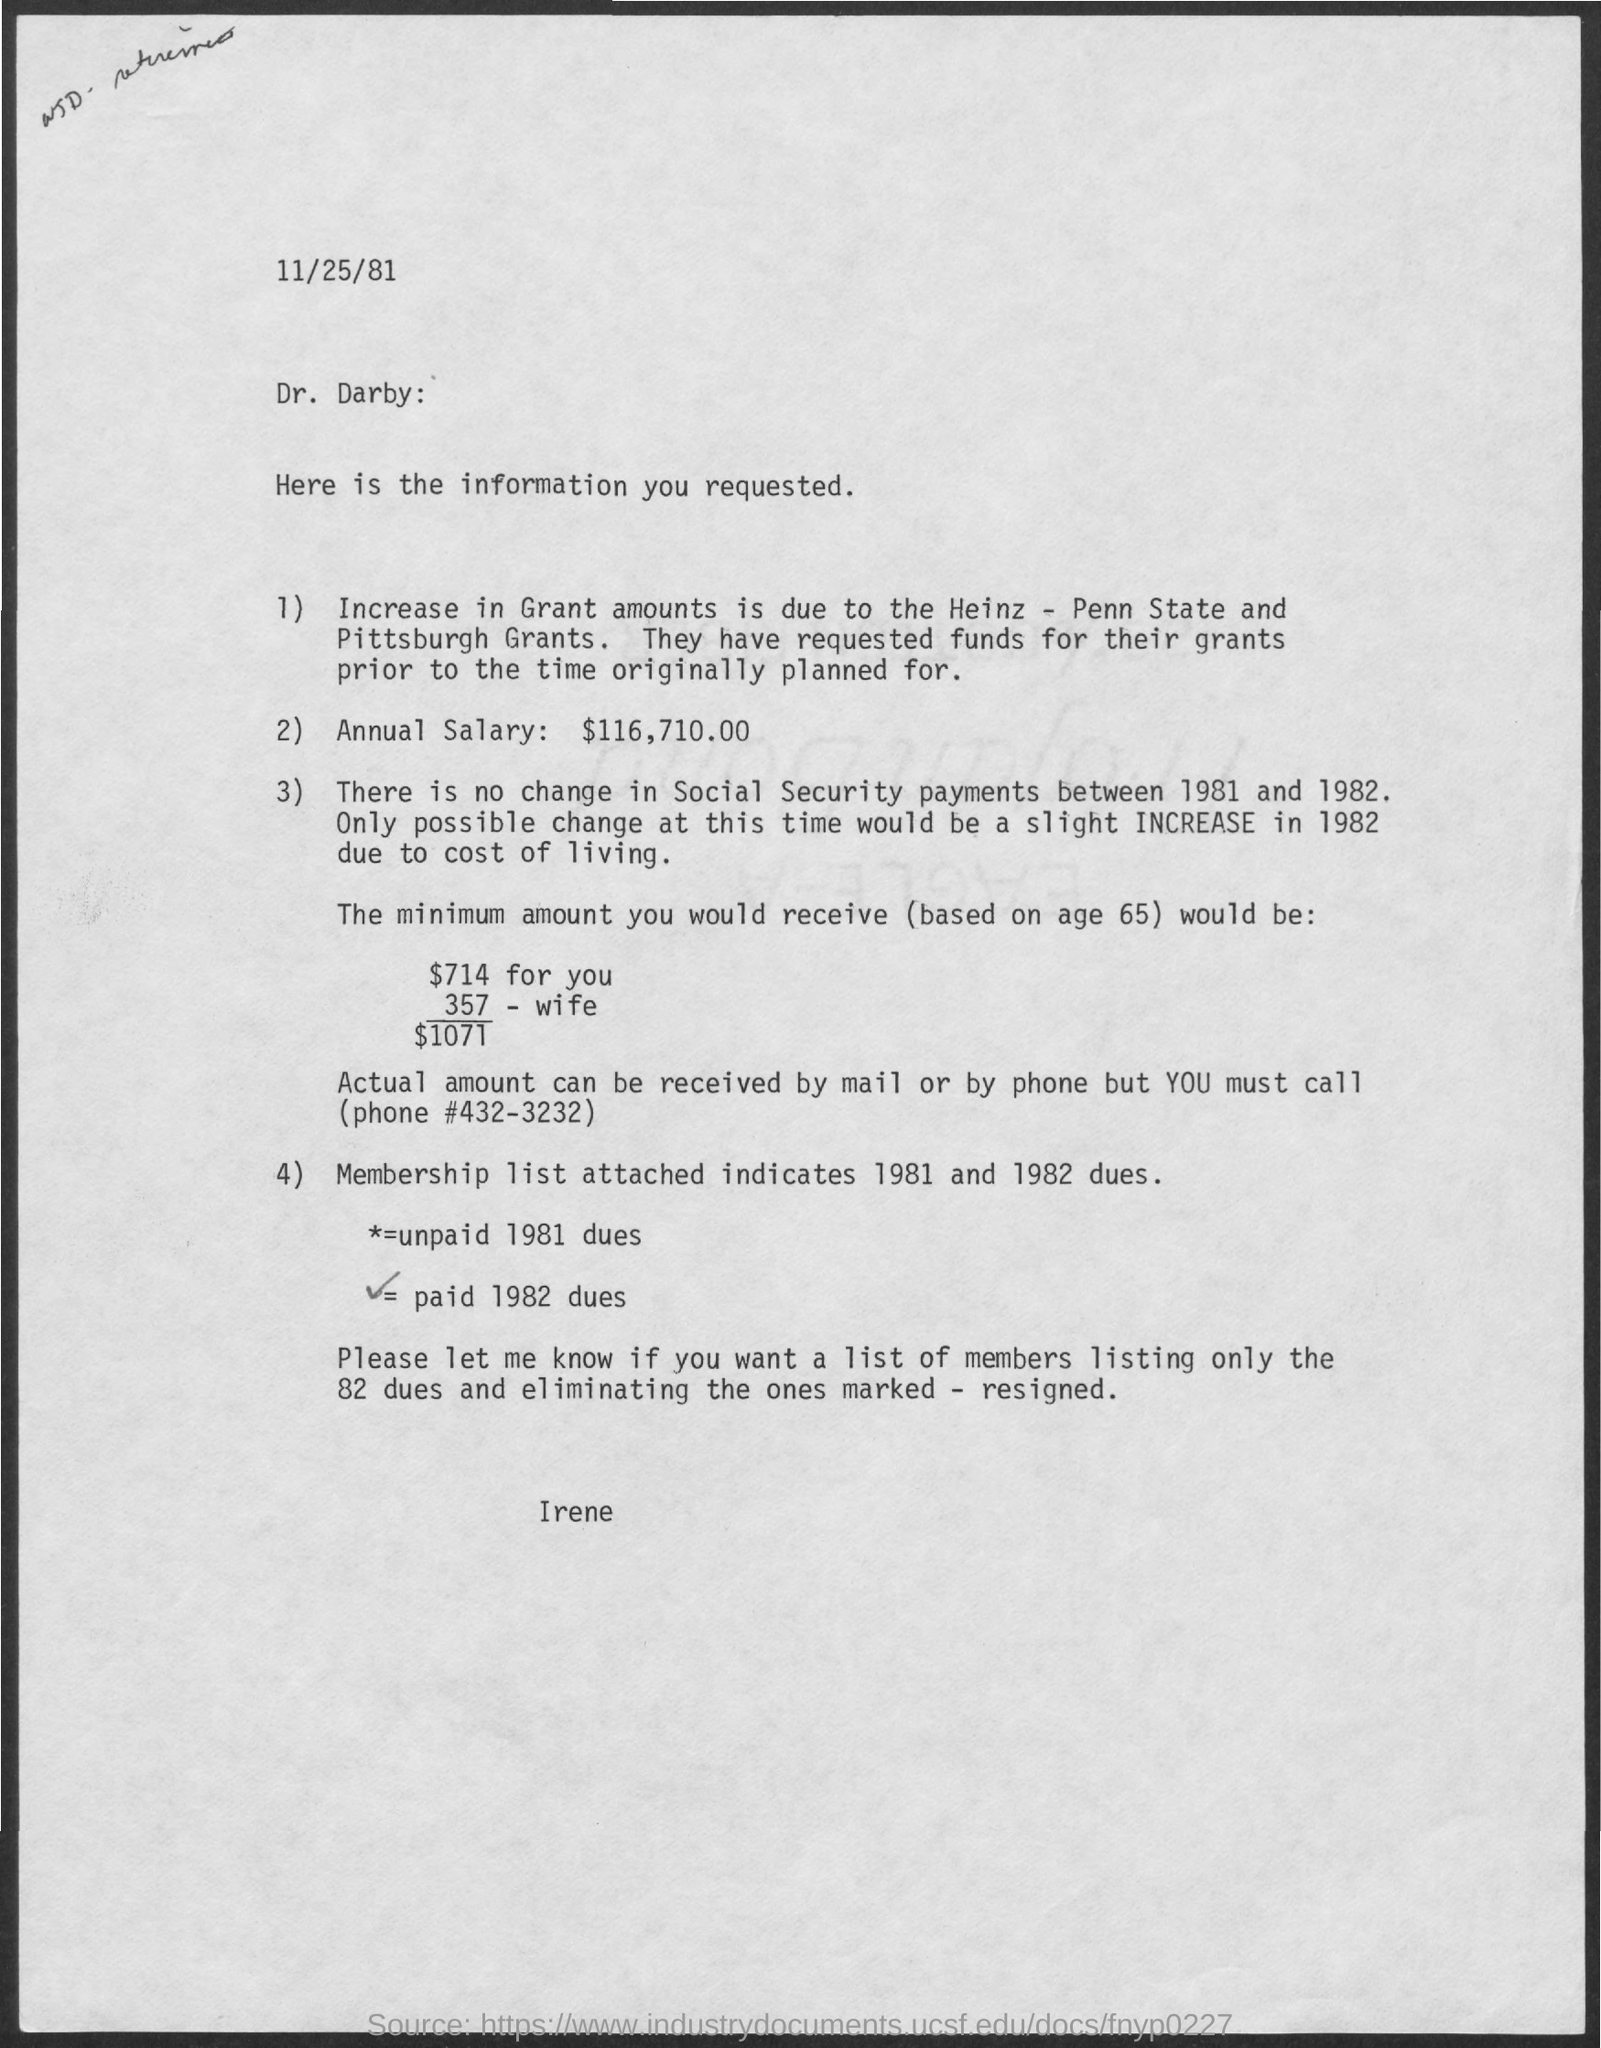Highlight a few significant elements in this photo. The increase in grant amounts is due to the partnership between Heinz and Penn State, with a focus on grant funding for projects in Pittsburgh. The annual salary is $116,710.00. The information is related to Dr. Darby. The date at the top of the page is November 25, 1981. 